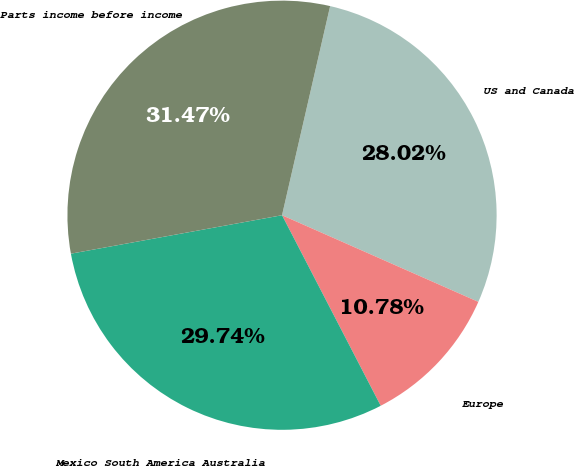Convert chart. <chart><loc_0><loc_0><loc_500><loc_500><pie_chart><fcel>US and Canada<fcel>Europe<fcel>Mexico South America Australia<fcel>Parts income before income<nl><fcel>28.02%<fcel>10.78%<fcel>29.74%<fcel>31.47%<nl></chart> 